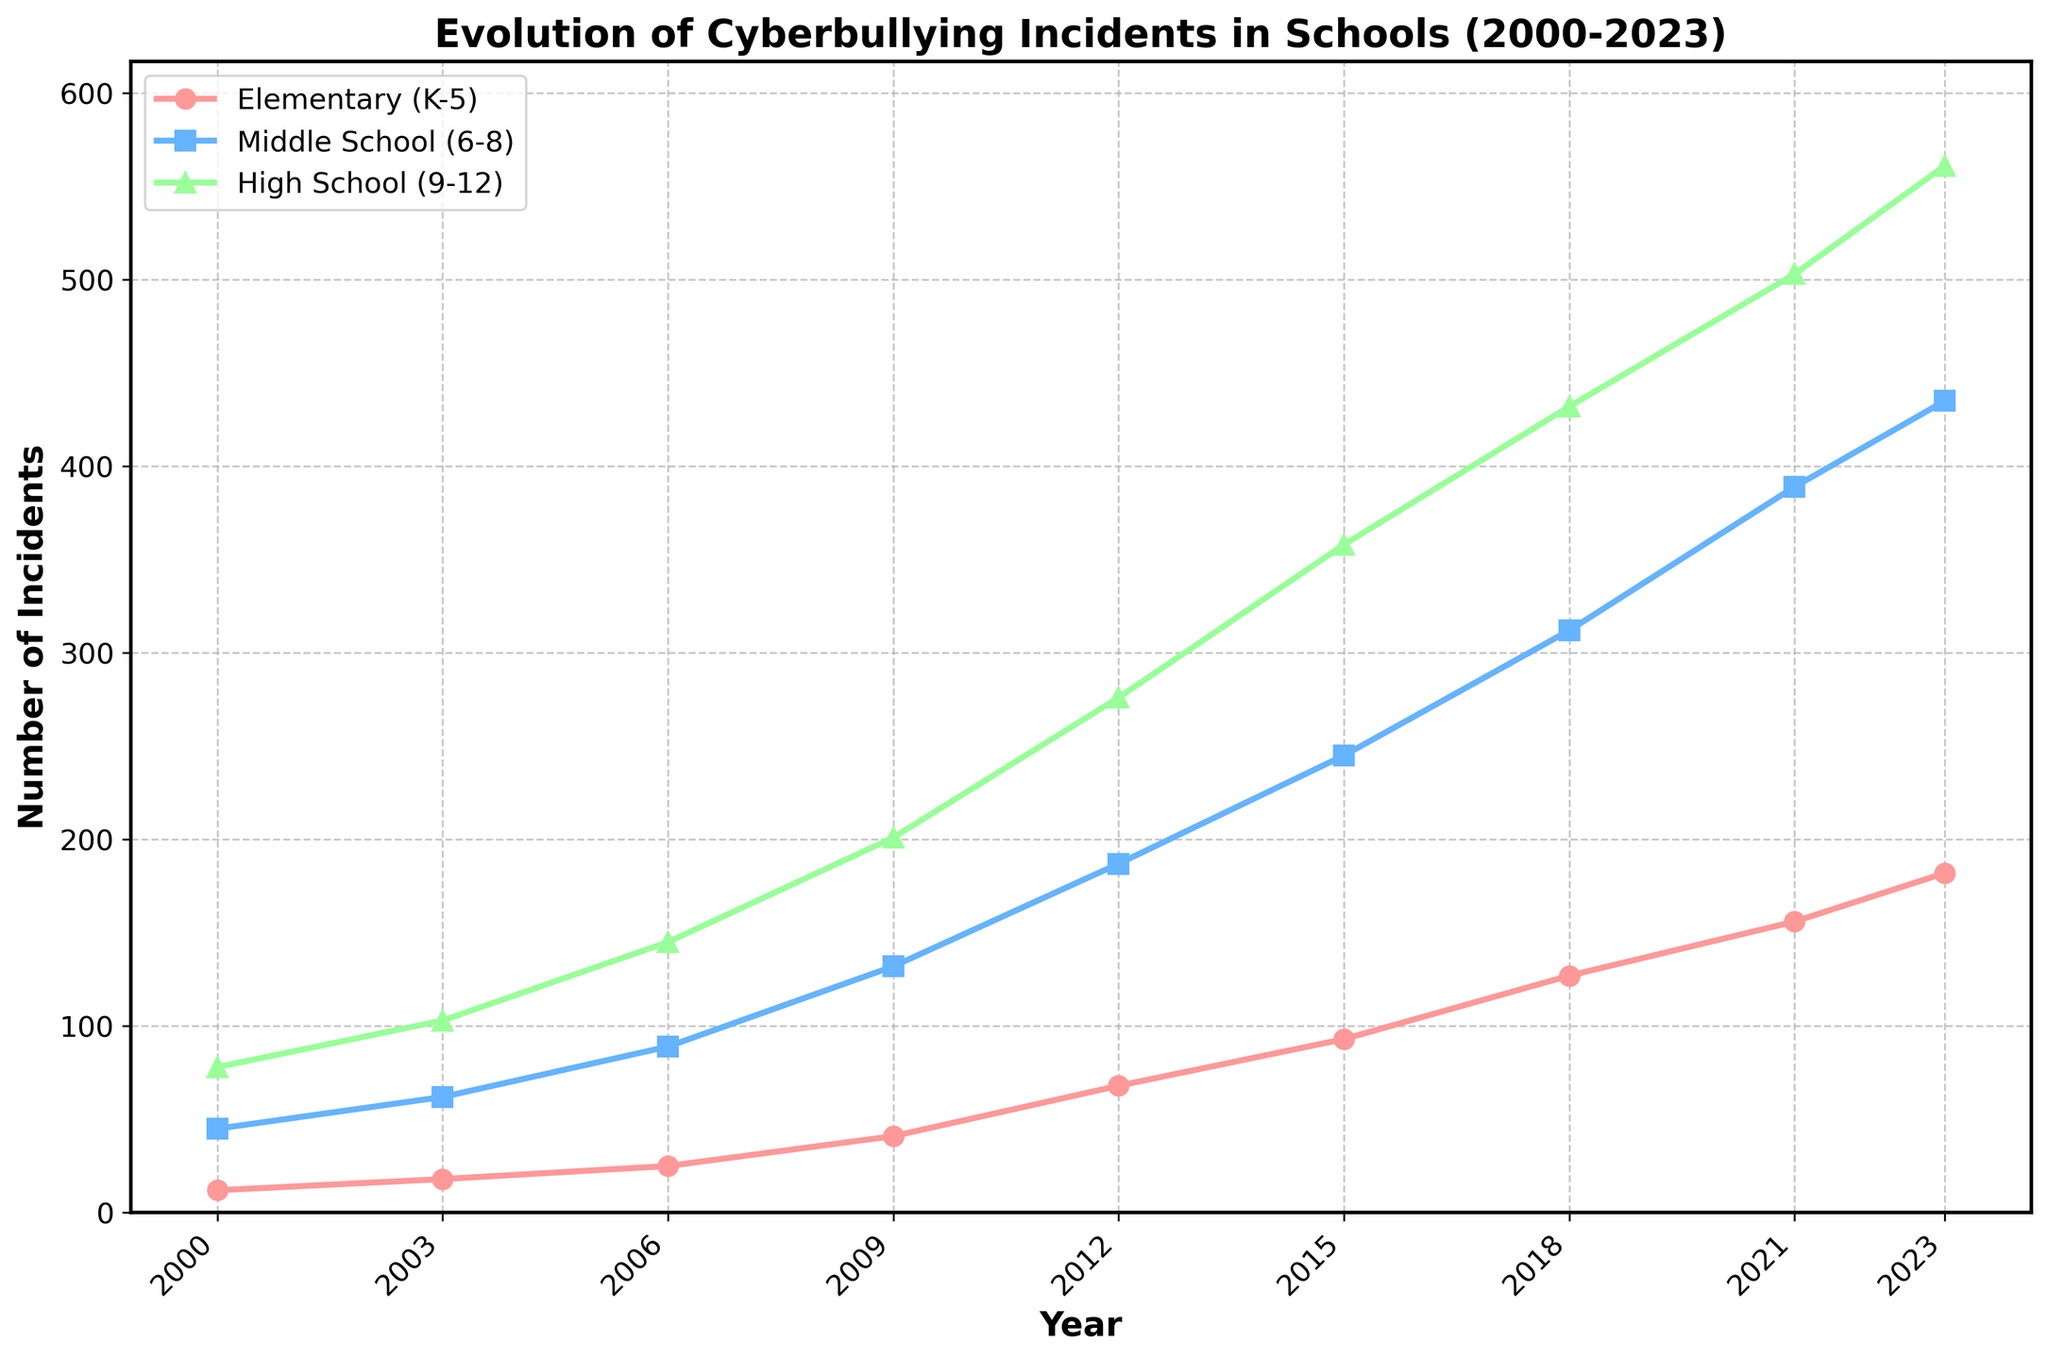When did the number of cyberbullying incidents in middle schools first exceed 100? Looking at the line chart, the number of incidents for middle schools first exceeds 100 between 2006 and 2009. The exact value for 2009 is 132, which is when it first surpasses 100.
Answer: 2009 Between 2000 and 2023, which grade level saw the highest increase in reported cyberbullying incidents? To find the highest increase, subtract the 2000 value from the 2023 value for each grade level:
- High School: 561 - 78 = 483
- Middle School: 435 - 45 = 390
- Elementary: 182 - 12 = 170
The highest increase is for High School.
Answer: High School What is the average number of cyberbullying incidents reported in elementary schools throughout the given years? Sum the incidents for elementary schools and divide by the number of years: (12 + 18 + 25 + 41 + 68 + 93 + 127 + 156 + 182) / 9 = 80.22
Answer: 80.22 Which year shows the largest single-year increase in cyberbullying incidents for high schools? Calculate the differences year-to-year for high schools:
- 2003: 103 - 78 = 25
- 2006: 145 - 103 = 42
- 2009: 201 - 145 = 56
- 2012: 276 - 201 = 75
- 2015: 358 - 276 = 82
- 2018: 432 - 358 = 74
- 2021: 503 - 432 = 71
- 2023: 561 - 503 = 58
The largest increase is 82, from 2012 to 2015.
Answer: 2015 How does the trend for cyberbullying incidents in elementary schools compare to high schools between 2000 and 2023? Observe the overall rising trend for both lines; however, high schools exhibit sharper and larger increases compared to elementary schools, particularly noticeable after 2009. Both increase, but high schools increase more rapidly.
Answer: High schools increase more rapidly By what factor did the reported cyberbullying incidents in middle schools grow from 2000 to 2023? Calculate the ratio of the 2023 value to the 2000 value for middle schools: 435 / 45 = 9.67. Middle school incidents grew by a factor of about 9.67.
Answer: 9.67 Which grade level had the smallest number of reported incidents in 2023? Look at the plot for 2023: 
- Elementary: 182
- Middle: 435
- High: 561
The smallest number is in elementary schools.
Answer: Elementary Do elementary schools ever surpass middle schools in the number of incidents during the given period? Examine the entire timeline in the chart. At no point do the elementary schools surpass the middle schools in reported incidents.
Answer: No What is the median number of cyberbullying incidents reported in high schools over the years? Sort the values and find the middle one:
78, 103, 145, 201, 276, 358, 432, 503, 561.
The middle value (5th) is 276.
Answer: 276 